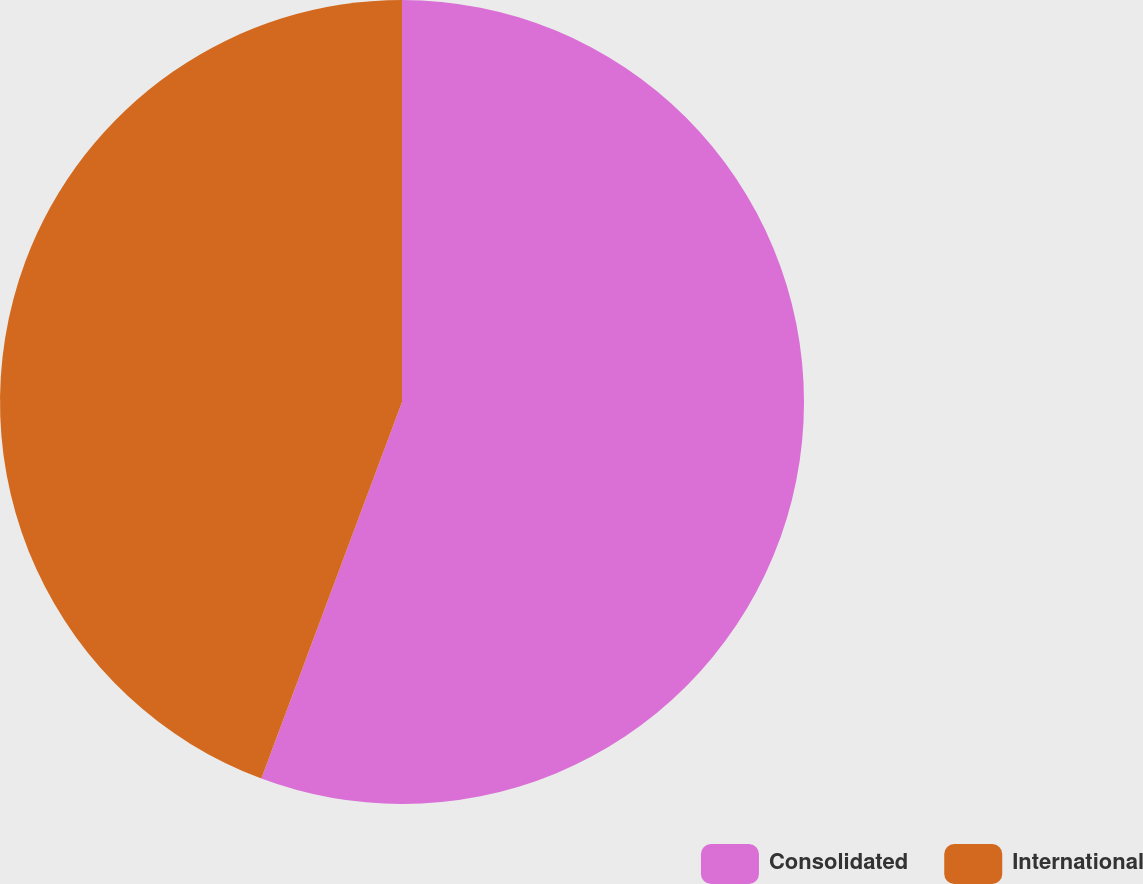Convert chart to OTSL. <chart><loc_0><loc_0><loc_500><loc_500><pie_chart><fcel>Consolidated<fcel>International<nl><fcel>55.69%<fcel>44.31%<nl></chart> 